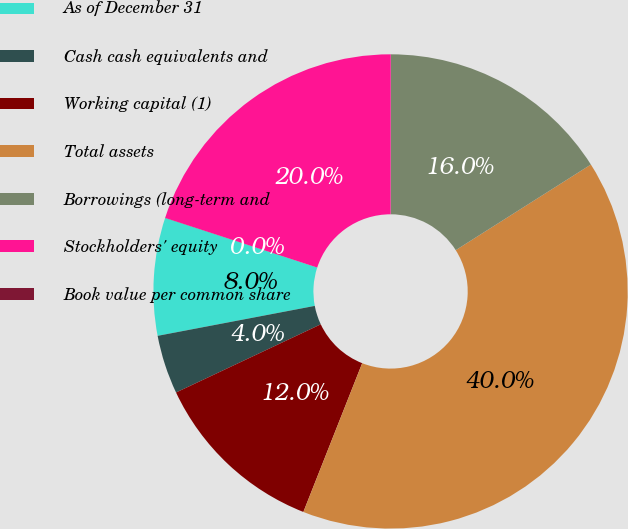Convert chart. <chart><loc_0><loc_0><loc_500><loc_500><pie_chart><fcel>As of December 31<fcel>Cash cash equivalents and<fcel>Working capital (1)<fcel>Total assets<fcel>Borrowings (long-term and<fcel>Stockholders' equity<fcel>Book value per common share<nl><fcel>8.01%<fcel>4.01%<fcel>12.0%<fcel>39.98%<fcel>16.0%<fcel>19.99%<fcel>0.01%<nl></chart> 